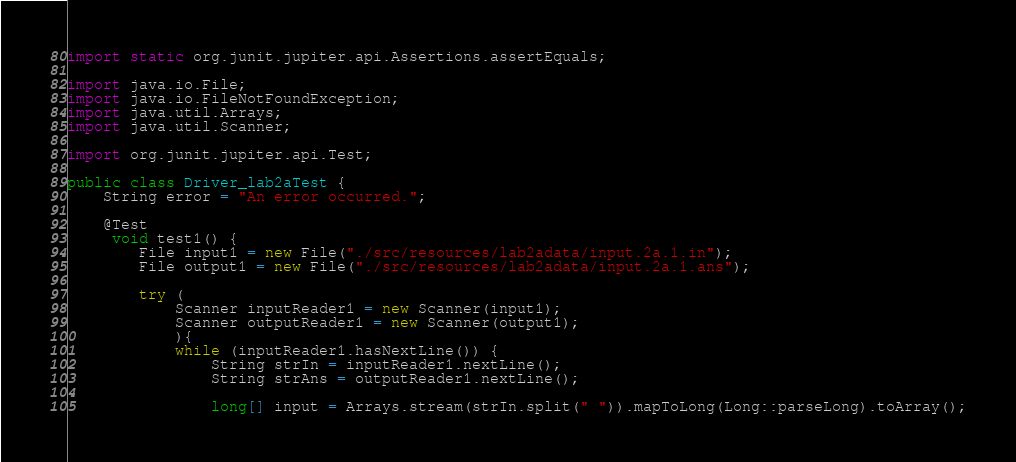Convert code to text. <code><loc_0><loc_0><loc_500><loc_500><_Java_>import static org.junit.jupiter.api.Assertions.assertEquals;

import java.io.File;
import java.io.FileNotFoundException;
import java.util.Arrays;
import java.util.Scanner;

import org.junit.jupiter.api.Test;

public class Driver_lab2aTest {
    String error = "An error occurred.";

    @Test
     void test1() {
        File input1 = new File("./src/resources/lab2adata/input.2a.1.in");
        File output1 = new File("./src/resources/lab2adata/input.2a.1.ans");

        try (
            Scanner inputReader1 = new Scanner(input1);
            Scanner outputReader1 = new Scanner(output1);
            ){
            while (inputReader1.hasNextLine()) {
                String strIn = inputReader1.nextLine();
                String strAns = outputReader1.nextLine();

                long[] input = Arrays.stream(strIn.split(" ")).mapToLong(Long::parseLong).toArray();</code> 